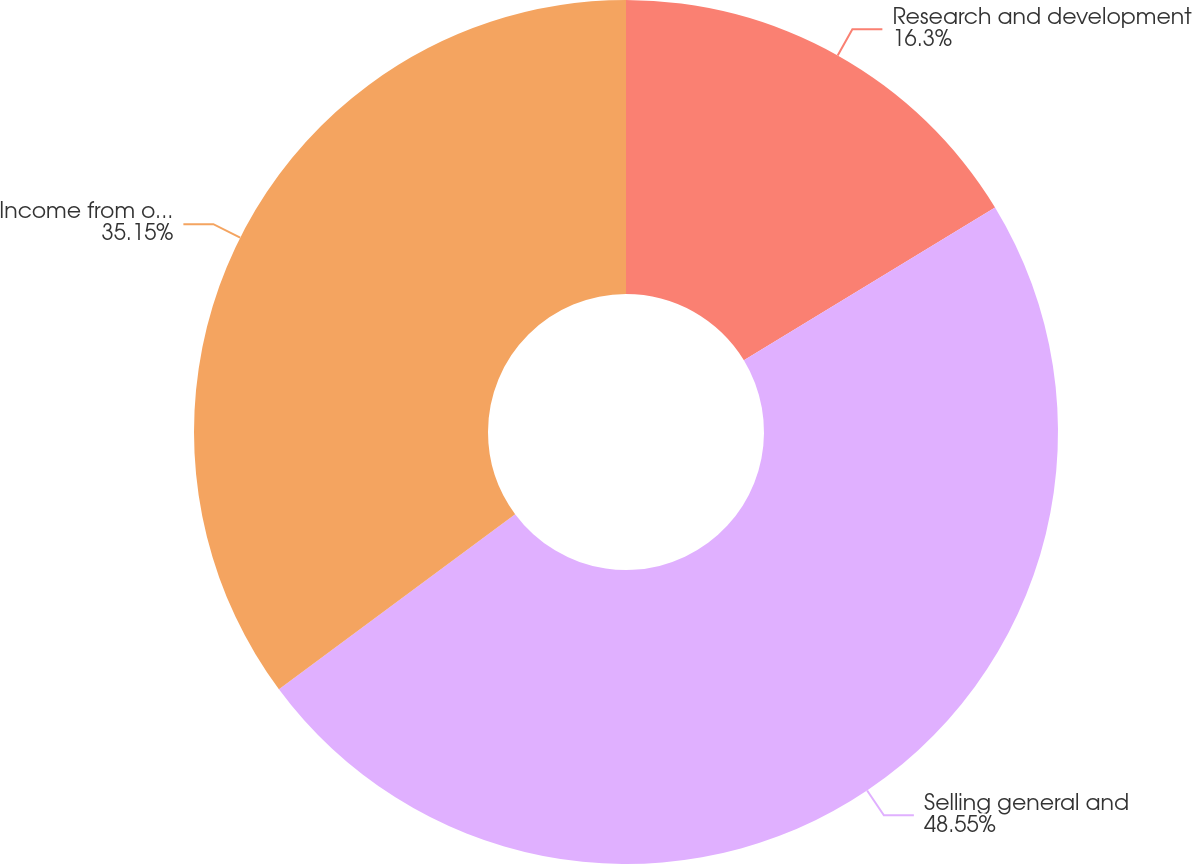Convert chart. <chart><loc_0><loc_0><loc_500><loc_500><pie_chart><fcel>Research and development<fcel>Selling general and<fcel>Income from operations<nl><fcel>16.3%<fcel>48.55%<fcel>35.15%<nl></chart> 